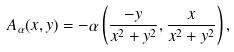Convert formula to latex. <formula><loc_0><loc_0><loc_500><loc_500>A _ { \alpha } ( x , y ) = - \alpha \left ( \frac { - y } { x ^ { 2 } + y ^ { 2 } } , \frac { x } { x ^ { 2 } + y ^ { 2 } } \right ) ,</formula> 